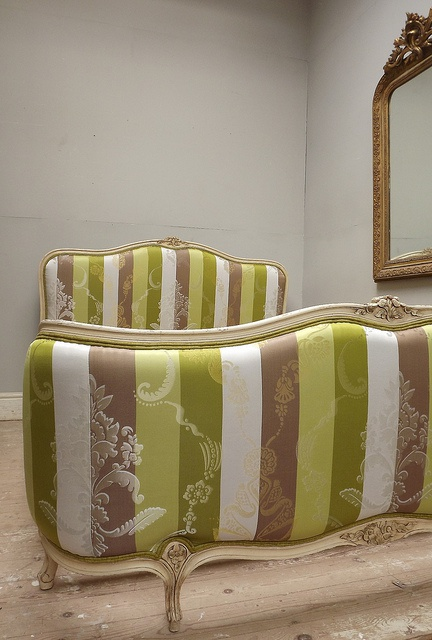Describe the objects in this image and their specific colors. I can see bed in gray, olive, and darkgray tones, couch in gray, olive, and darkgray tones, and couch in gray, tan, darkgray, and olive tones in this image. 